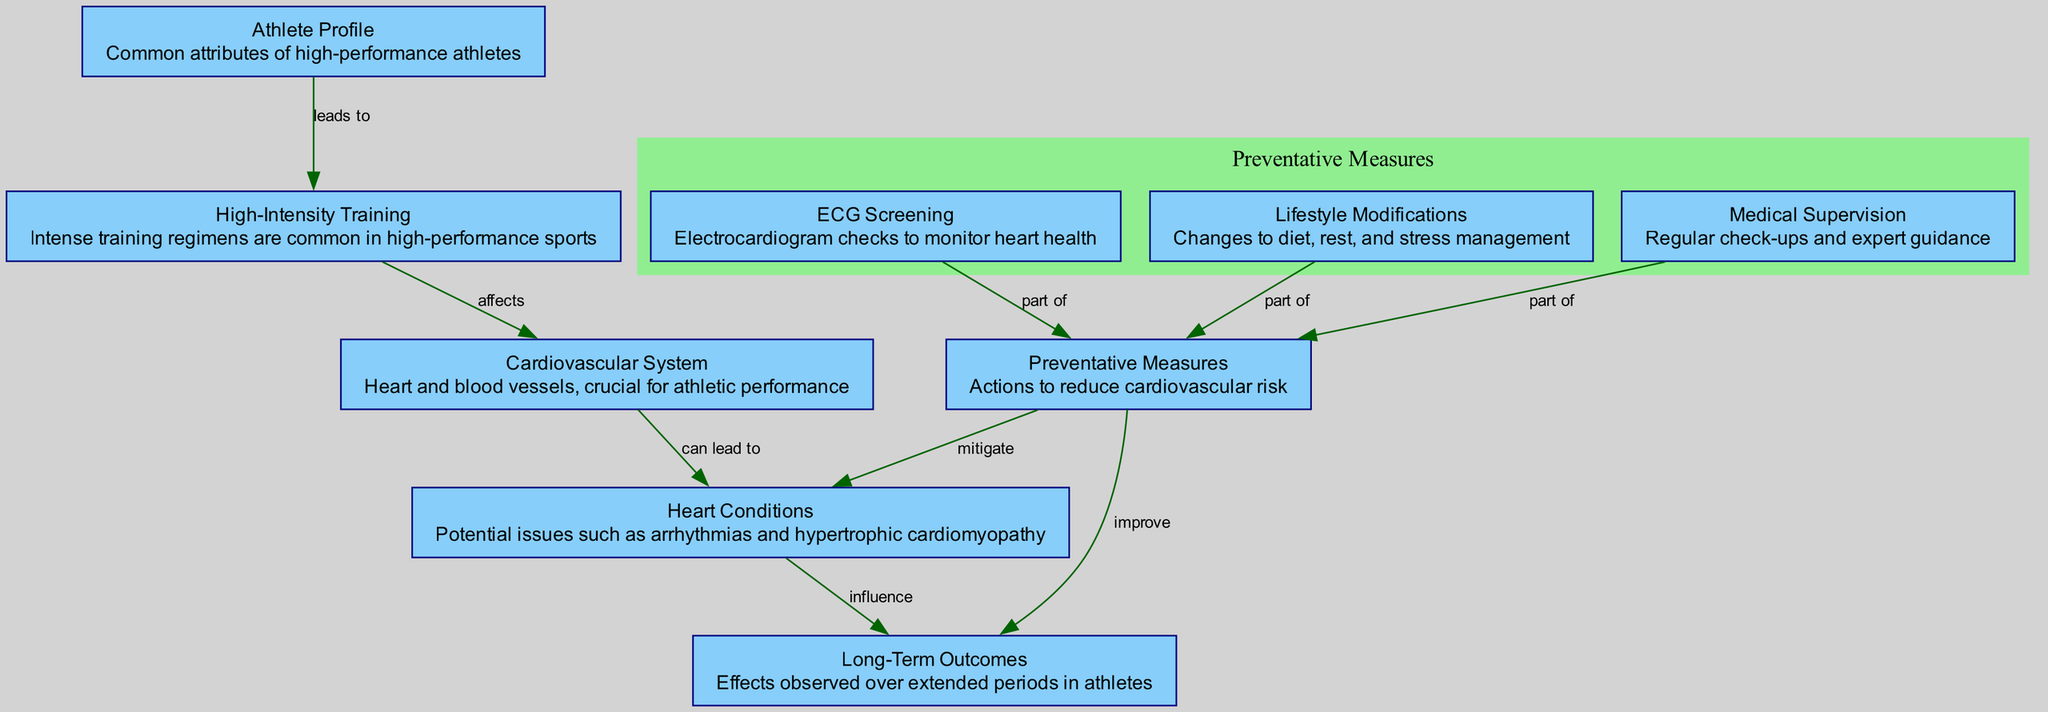What are the common attributes of high-performance athletes? The diagram indicates that the "Athlete Profile" node represents common attributes of high-performance athletes.
Answer: Common attributes of high-performance athletes How many nodes are present in the diagram? By counting the nodes listed in the diagram data, we find there are 9 distinct nodes identified.
Answer: 9 What does high-intensity training affect? According to the diagram, the edge from "High-Intensity Training" to "Cardiovascular System" indicates that it affects the cardiovascular system.
Answer: Cardiovascular System What can lead to cardiovascular conditions? The connection between "Cardiovascular System" and "Heart Conditions" shows that issues within the cardiovascular system can lead to heart conditions.
Answer: Cardiovascular System Which preventive measure is part of monitoring heart health? The "ECG Screening" node specifies that it is part of preventative measures aimed at monitoring heart health according to the diagram structure.
Answer: ECG Screening How do preventative measures influence long-term outcomes? The edge from "Preventative Measures" to "Long-Term Outcomes" signifies that implementing preventative measures can improve long-term outcomes for athletes, making this relationship key to understanding the benefits.
Answer: Improve What heart conditions can be influenced by lifestyle modifications? The diagram illustrates that "Preventative Measures," which include "Lifestyle Modifications," can mitigate heart conditions as indicated by the edges leading away from "Preventative Measures."
Answer: Heart Conditions Which components are included in preventative measures? The diagram lists three components, which are "ECG Screening," "Lifestyle Modifications," and "Medical Supervision" all part of "Preventative Measures."
Answer: ECG Screening, Lifestyle Modifications, Medical Supervision What influences long-term outcomes in athletes? The diagram shows an edge from "Heart Conditions" to "Long-Term Outcomes," meaning heart conditions can influence long-term outcomes, linking the states of health directly to outcomes in athletes' lives.
Answer: Heart Conditions 